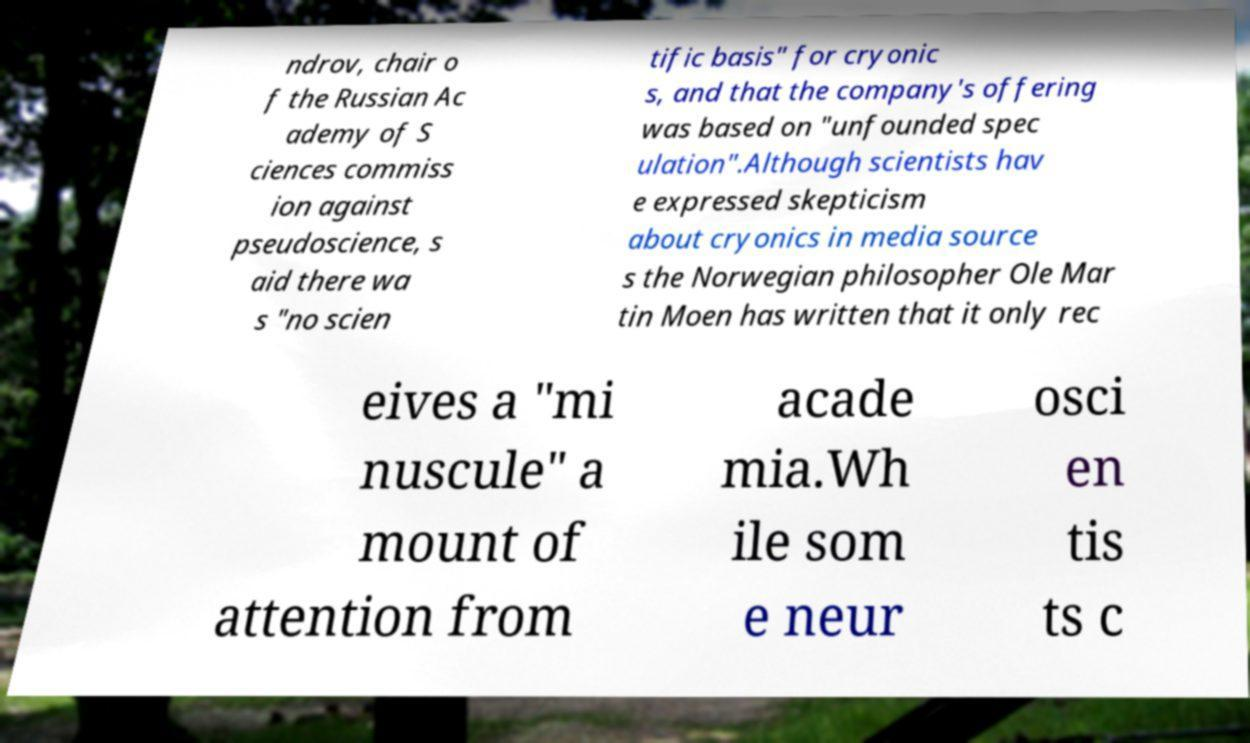What messages or text are displayed in this image? I need them in a readable, typed format. ndrov, chair o f the Russian Ac ademy of S ciences commiss ion against pseudoscience, s aid there wa s "no scien tific basis" for cryonic s, and that the company's offering was based on "unfounded spec ulation".Although scientists hav e expressed skepticism about cryonics in media source s the Norwegian philosopher Ole Mar tin Moen has written that it only rec eives a "mi nuscule" a mount of attention from acade mia.Wh ile som e neur osci en tis ts c 